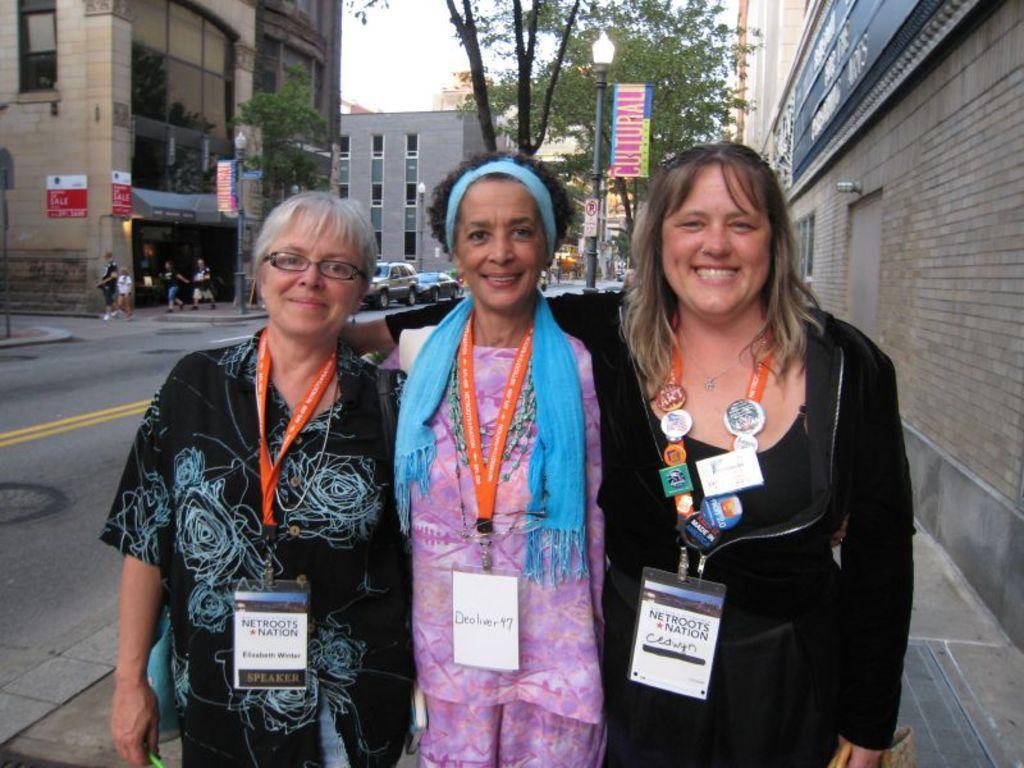Could you give a brief overview of what you see in this image? In this image we can see there are three persons standing with a smile on their face, beside them there are buildings. On the left side of the image there are buildings and trees, in front of the road there is a road. On the road there are few people walking and some vehicles are moving and we can there are few poles. In the background there is a sky. 